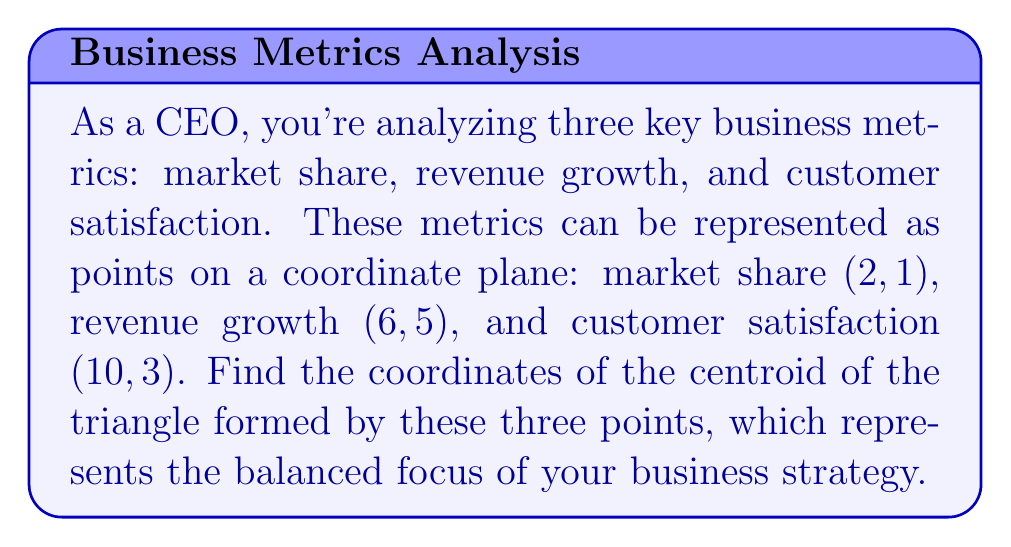Solve this math problem. To find the centroid of a triangle, we need to follow these steps:

1. Identify the coordinates of the three vertices:
   A(2, 1), B(6, 5), and C(10, 3)

2. The centroid formula for a triangle is:
   $$(\frac{x_1 + x_2 + x_3}{3}, \frac{y_1 + y_2 + y_3}{3})$$
   where $(x_1, y_1)$, $(x_2, y_2)$, and $(x_3, y_3)$ are the coordinates of the three vertices.

3. Calculate the x-coordinate of the centroid:
   $$x = \frac{x_1 + x_2 + x_3}{3} = \frac{2 + 6 + 10}{3} = \frac{18}{3} = 6$$

4. Calculate the y-coordinate of the centroid:
   $$y = \frac{y_1 + y_2 + y_3}{3} = \frac{1 + 5 + 3}{3} = \frac{9}{3} = 3$$

5. Therefore, the coordinates of the centroid are (6, 3).

[asy]
unitsize(0.5cm);
draw((0,0)--(12,6), gray);
draw((0,6)--(12,0), gray);
for(int i=0; i<=12; ++i) {
  draw((i,0)--(i,6), gray+opacity(0.3));
  draw((0,i)--(12,i), gray+opacity(0.3));
}
dot((2,1)); dot((6,5)); dot((10,3)); dot((6,3), red);
label("A(2,1)", (2,1), SW);
label("B(6,5)", (6,5), N);
label("C(10,3)", (10,3), SE);
label("Centroid (6,3)", (6,3), NE, red);
draw((2,1)--(6,5)--(10,3)--cycle);
[/asy]
Answer: (6, 3) 